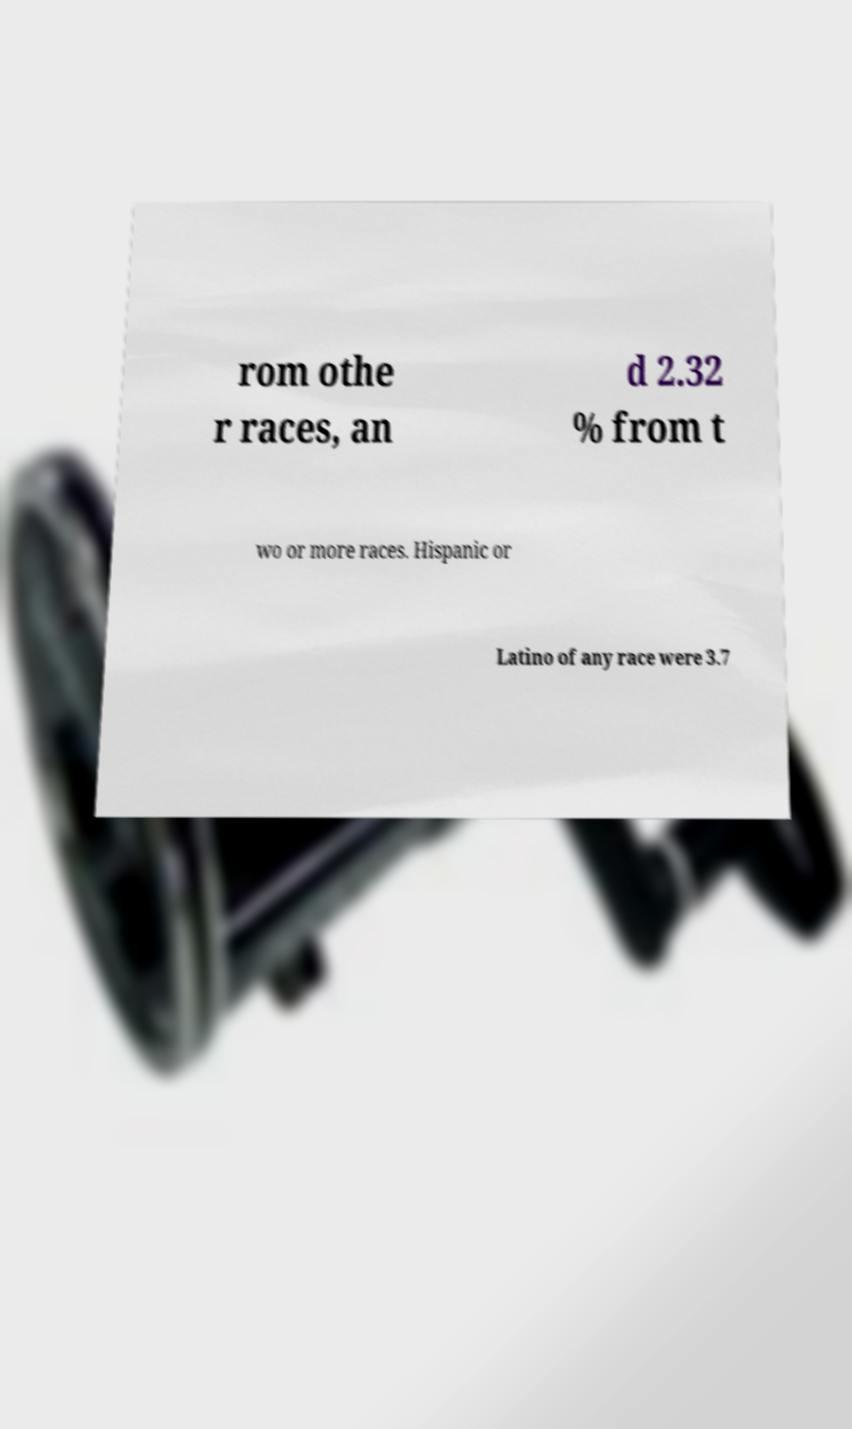Could you assist in decoding the text presented in this image and type it out clearly? rom othe r races, an d 2.32 % from t wo or more races. Hispanic or Latino of any race were 3.7 